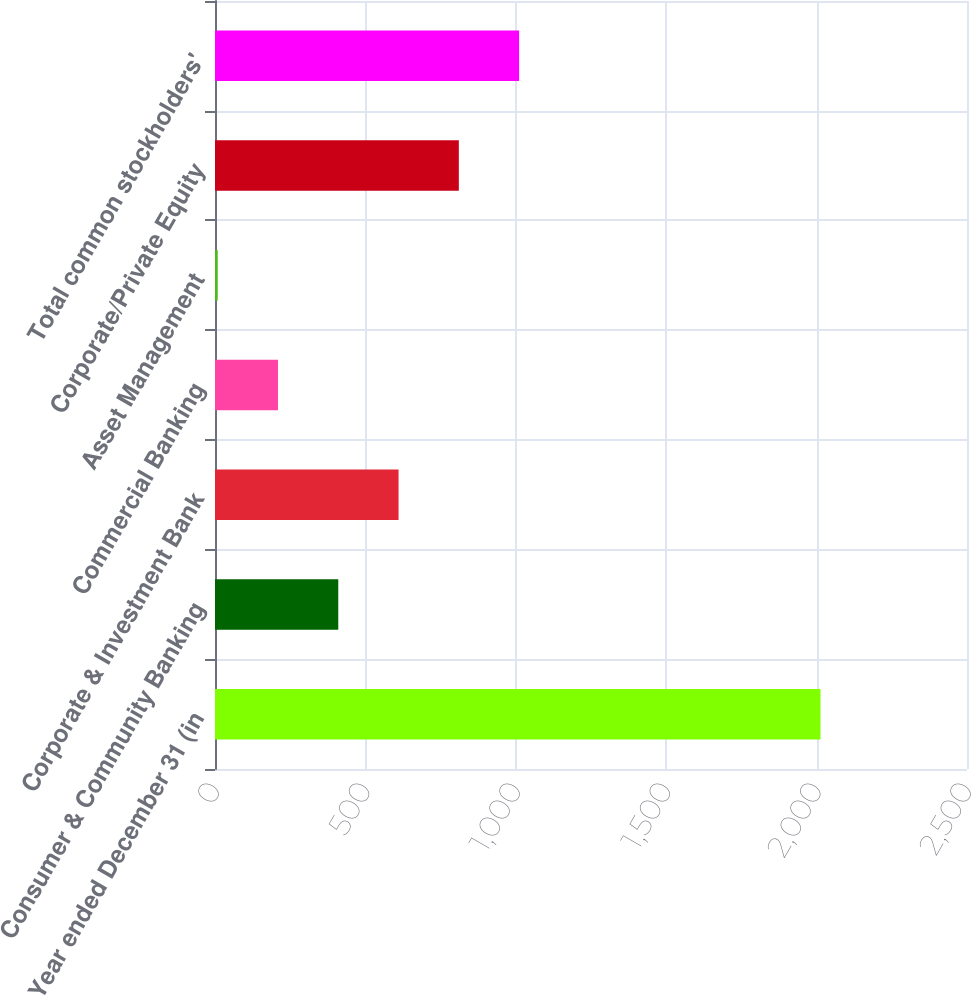Convert chart. <chart><loc_0><loc_0><loc_500><loc_500><bar_chart><fcel>Year ended December 31 (in<fcel>Consumer & Community Banking<fcel>Corporate & Investment Bank<fcel>Commercial Banking<fcel>Asset Management<fcel>Corporate/Private Equity<fcel>Total common stockholders'<nl><fcel>2013<fcel>409.8<fcel>610.2<fcel>209.4<fcel>9<fcel>810.6<fcel>1011<nl></chart> 